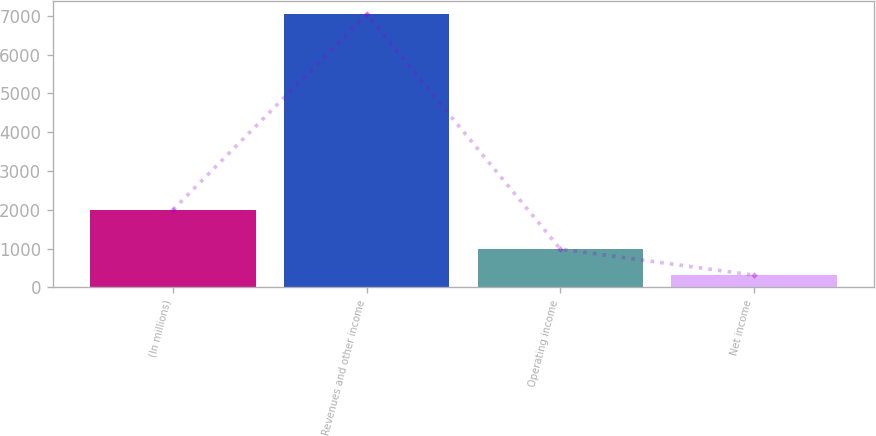Convert chart. <chart><loc_0><loc_0><loc_500><loc_500><bar_chart><fcel>(In millions)<fcel>Revenues and other income<fcel>Operating income<fcel>Net income<nl><fcel>2003<fcel>7036<fcel>990.7<fcel>319<nl></chart> 